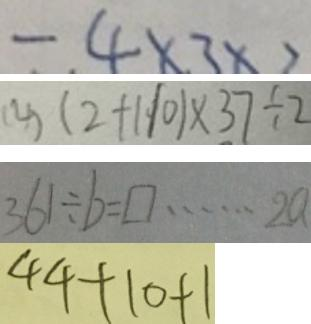<formula> <loc_0><loc_0><loc_500><loc_500>- 4 \times 3 \times 2 
 ( 4 ) ( 2 + 1 1 0 ) \times 3 7 \div 2 
 3 6 1 \div b = \square \cdots 2 a 
 4 4 + 1 0 + 1</formula> 